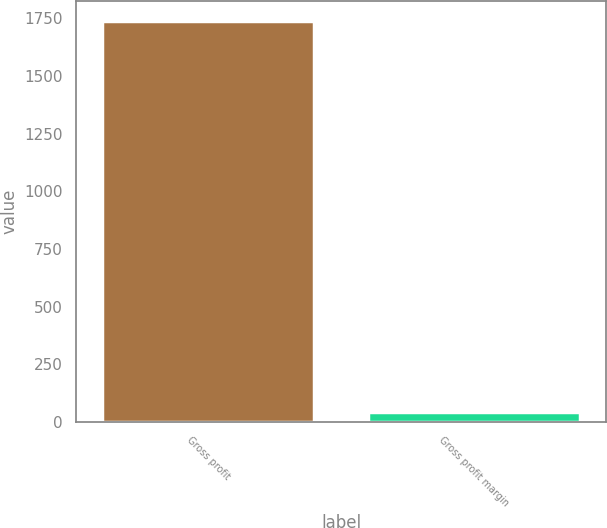<chart> <loc_0><loc_0><loc_500><loc_500><bar_chart><fcel>Gross profit<fcel>Gross profit margin<nl><fcel>1737.3<fcel>40.4<nl></chart> 